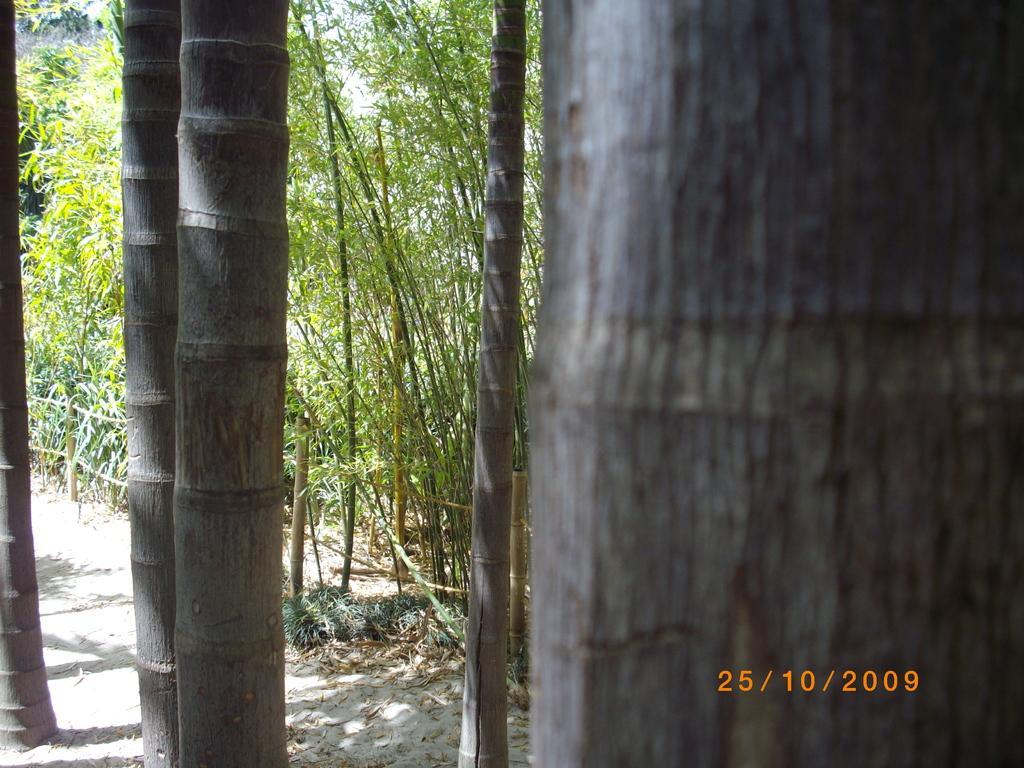How would you summarize this image in a sentence or two? This image consists of trees and plants. At the bottom, there is sand on the ground. 